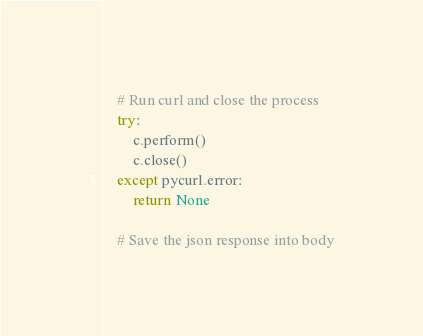Convert code to text. <code><loc_0><loc_0><loc_500><loc_500><_Python_>
    # Run curl and close the process
    try:
        c.perform()
        c.close()
    except pycurl.error:
        return None

    # Save the json response into body</code> 